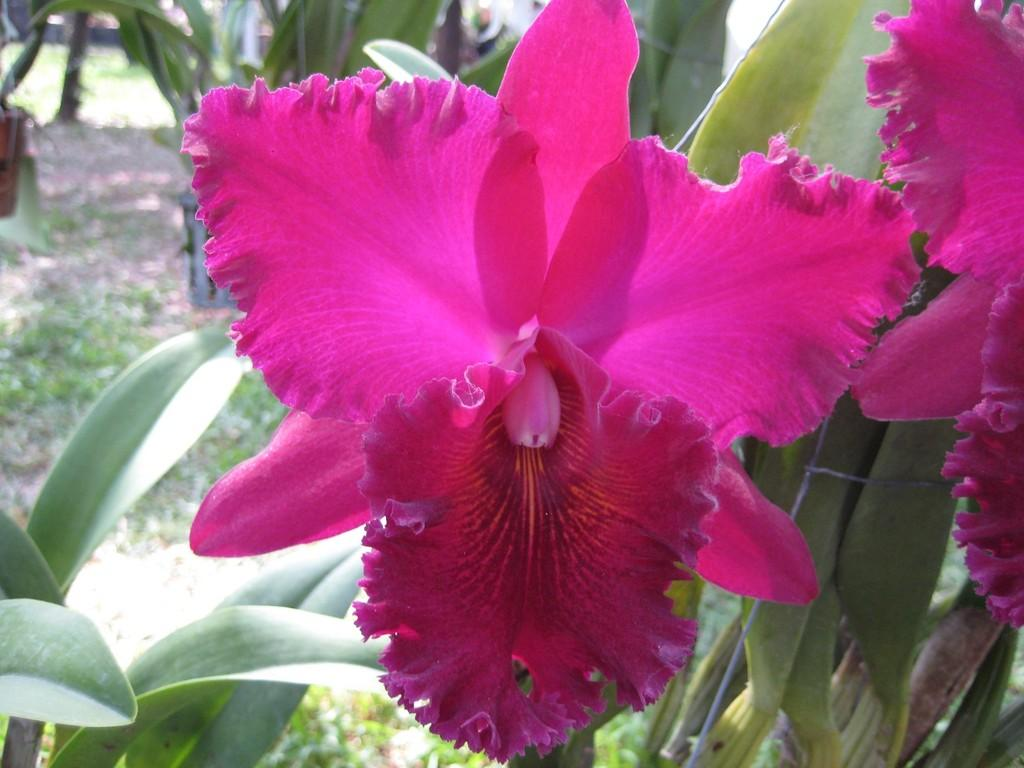What type of flower is in the image? There is a pink flower in the image. What else can be seen in the image besides the flower? There are leaves in the image. What is at the bottom of the image? There is grass at the bottom of the image. How many beans are present in the image? There are no beans visible in the image. 